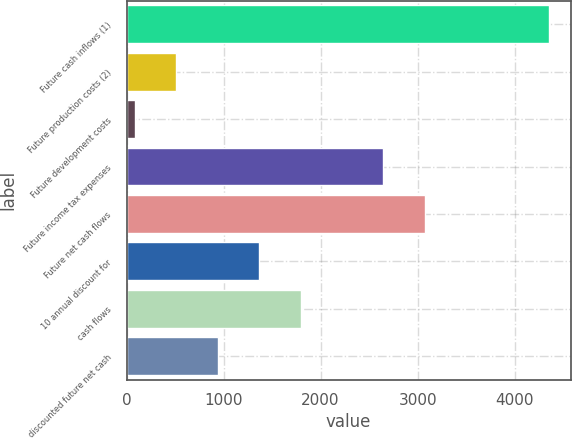<chart> <loc_0><loc_0><loc_500><loc_500><bar_chart><fcel>Future cash inflows (1)<fcel>Future production costs (2)<fcel>Future development costs<fcel>Future income tax expenses<fcel>Future net cash flows<fcel>10 annual discount for<fcel>cash flows<fcel>discounted future net cash<nl><fcel>4358<fcel>510.5<fcel>83<fcel>2648<fcel>3075.5<fcel>1365.5<fcel>1793<fcel>938<nl></chart> 